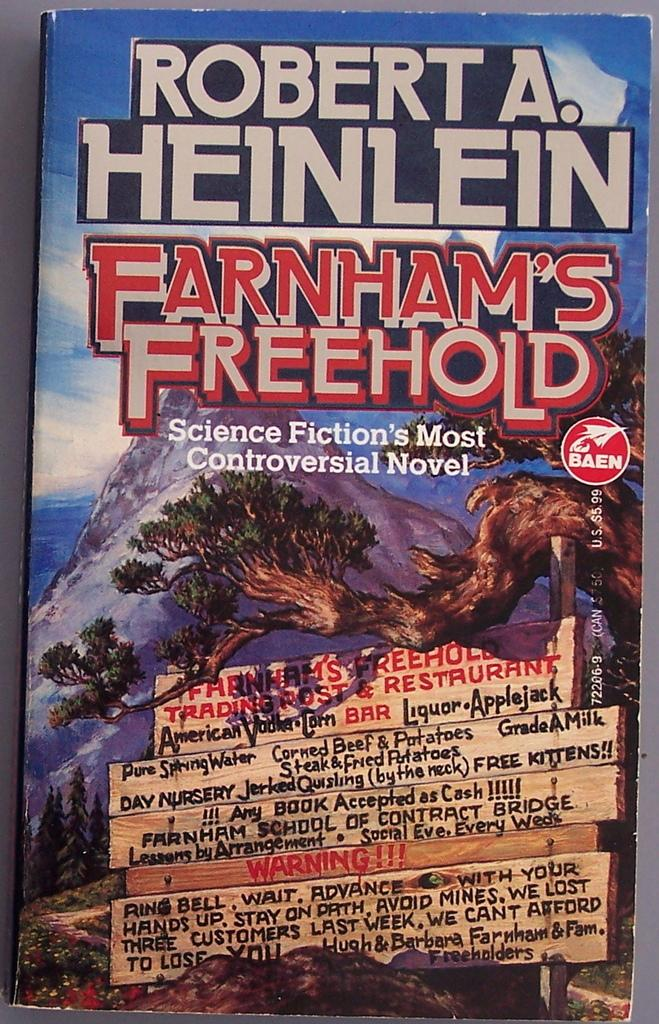<image>
Present a compact description of the photo's key features. a cover of a science fiction book named Farnham's Freehold 